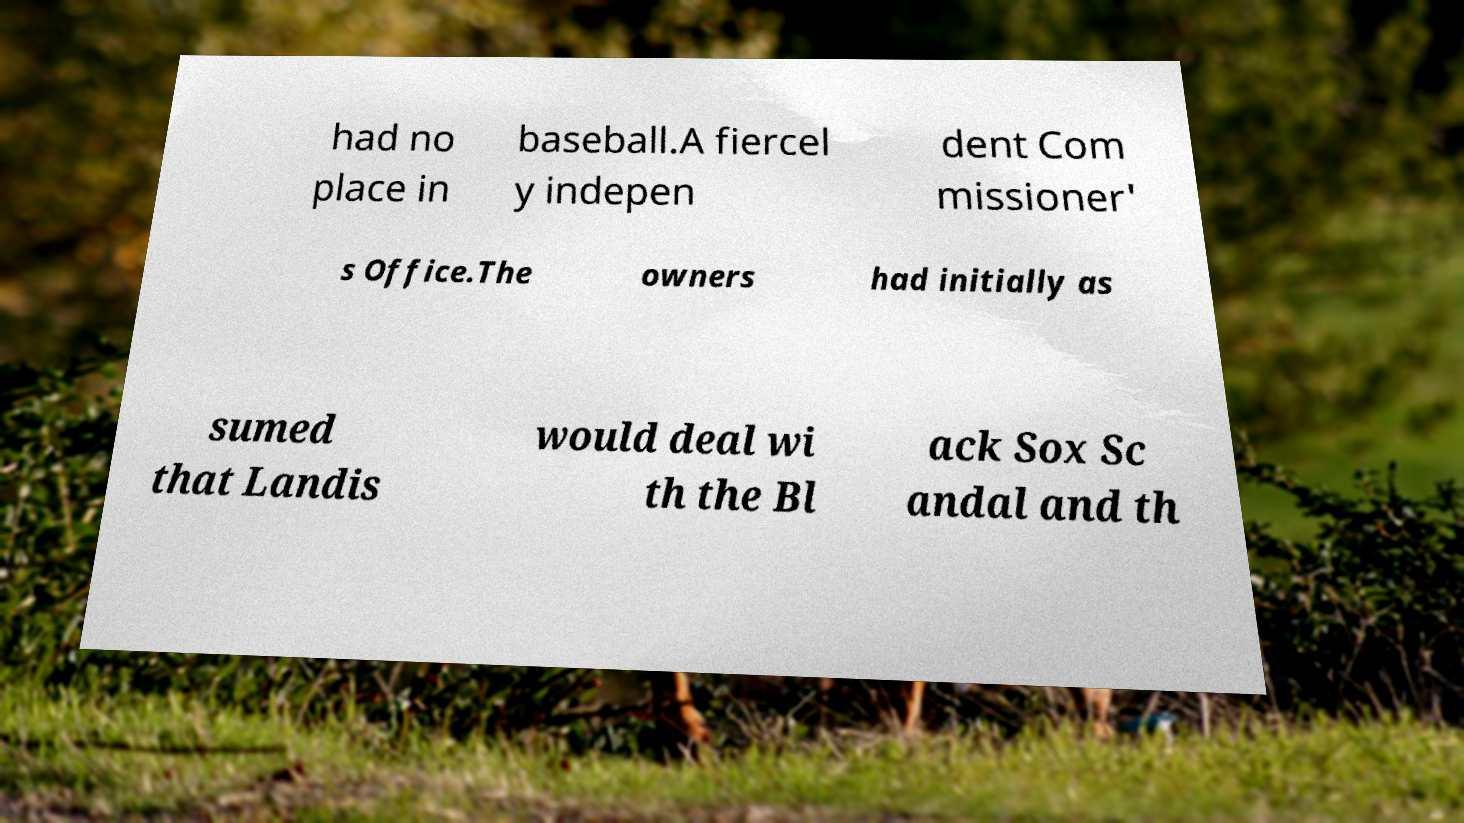There's text embedded in this image that I need extracted. Can you transcribe it verbatim? had no place in baseball.A fiercel y indepen dent Com missioner' s Office.The owners had initially as sumed that Landis would deal wi th the Bl ack Sox Sc andal and th 